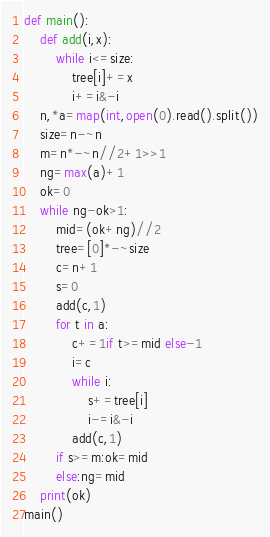Convert code to text. <code><loc_0><loc_0><loc_500><loc_500><_Python_>def main():
    def add(i,x):
        while i<=size:
            tree[i]+=x
            i+=i&-i
    n,*a=map(int,open(0).read().split())
    size=n-~n
    m=n*-~n//2+1>>1
    ng=max(a)+1
    ok=0
    while ng-ok>1:
        mid=(ok+ng)//2
        tree=[0]*-~size
        c=n+1
        s=0
        add(c,1)
        for t in a:
            c+=1if t>=mid else-1
            i=c
            while i:
                s+=tree[i]
                i-=i&-i
            add(c,1)
        if s>=m:ok=mid
        else:ng=mid
    print(ok)
main()</code> 